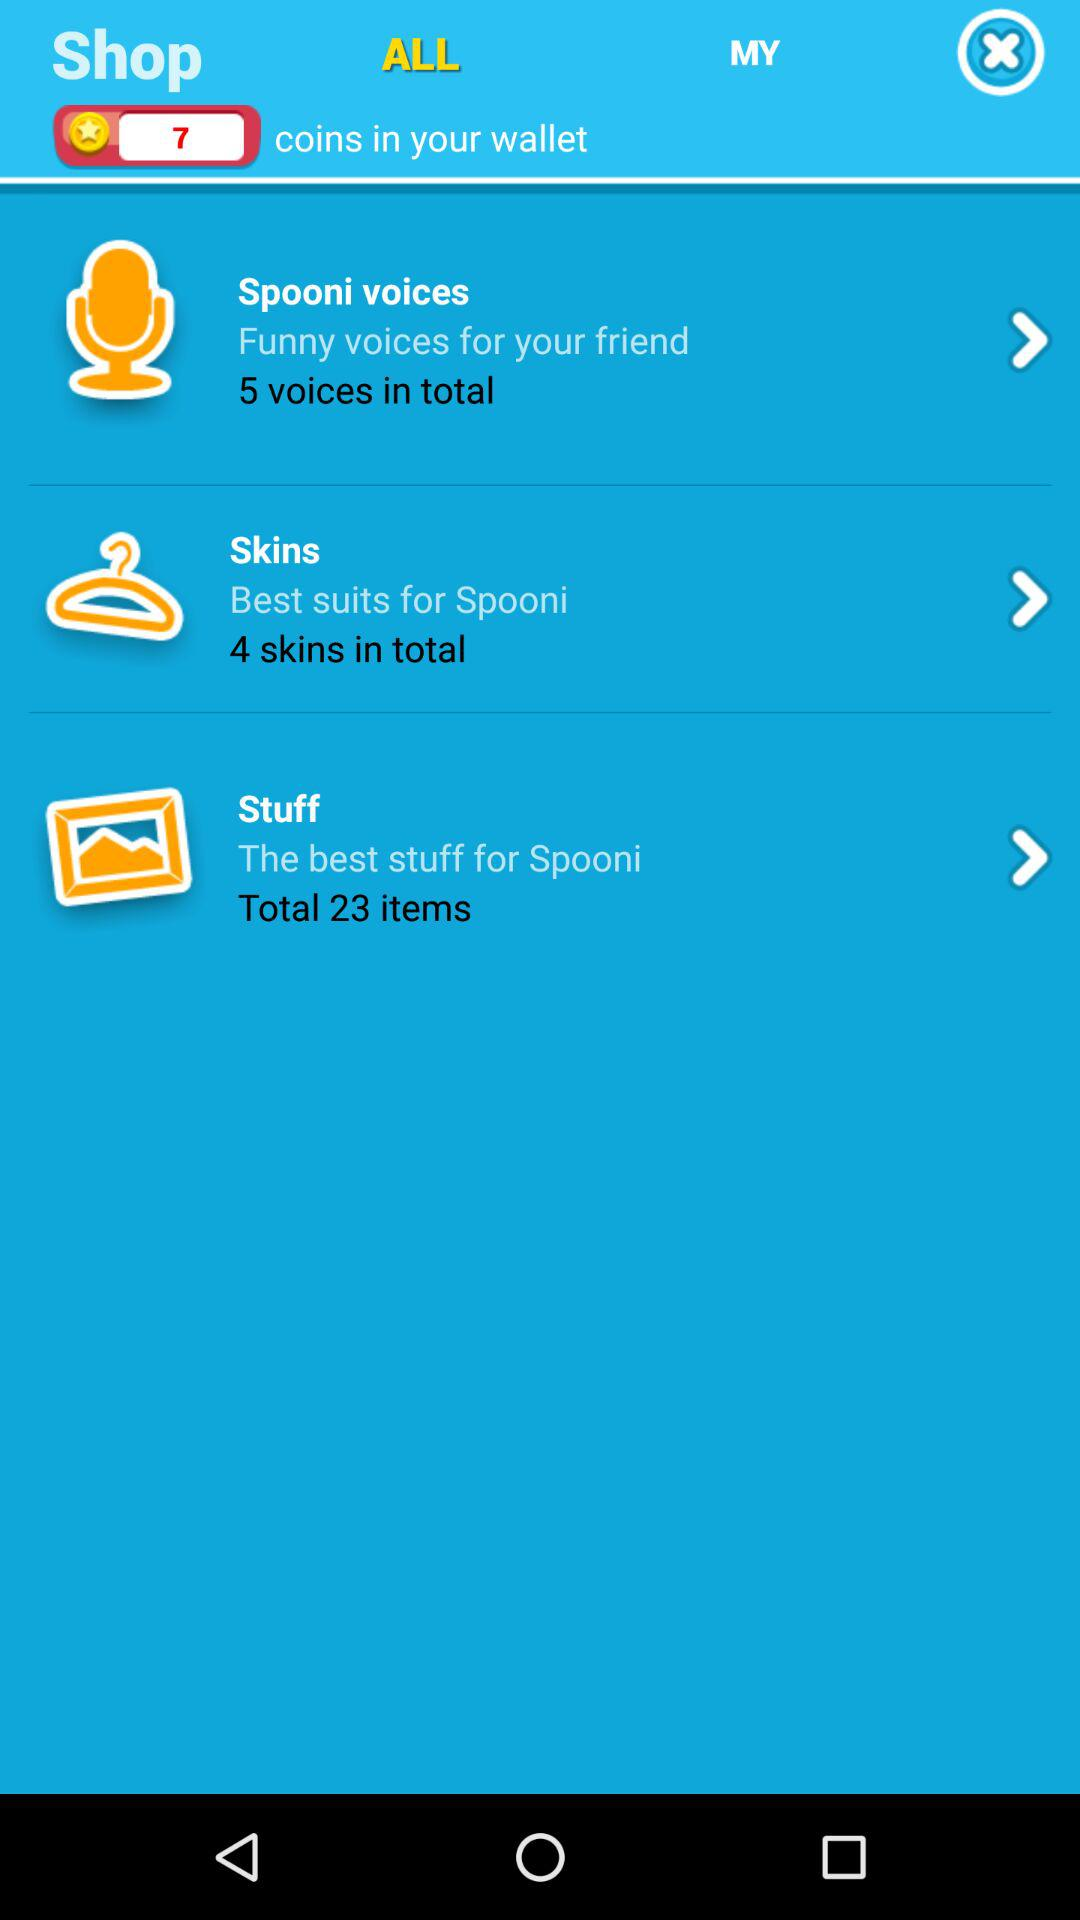In what option are 5 voices available? Five voices are available in "Spooni voices". 